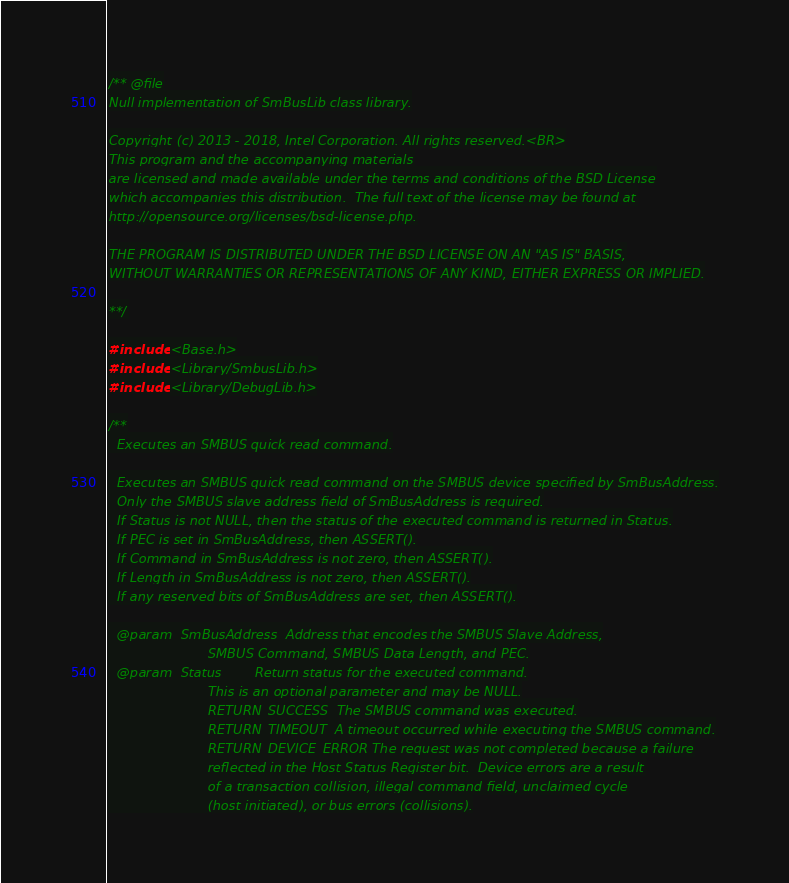<code> <loc_0><loc_0><loc_500><loc_500><_C_>/** @file
Null implementation of SmBusLib class library.

Copyright (c) 2013 - 2018, Intel Corporation. All rights reserved.<BR>
This program and the accompanying materials
are licensed and made available under the terms and conditions of the BSD License
which accompanies this distribution.  The full text of the license may be found at
http://opensource.org/licenses/bsd-license.php.

THE PROGRAM IS DISTRIBUTED UNDER THE BSD LICENSE ON AN "AS IS" BASIS,
WITHOUT WARRANTIES OR REPRESENTATIONS OF ANY KIND, EITHER EXPRESS OR IMPLIED.

**/

#include <Base.h>
#include <Library/SmbusLib.h>
#include <Library/DebugLib.h>

/**
  Executes an SMBUS quick read command.

  Executes an SMBUS quick read command on the SMBUS device specified by SmBusAddress.
  Only the SMBUS slave address field of SmBusAddress is required.
  If Status is not NULL, then the status of the executed command is returned in Status.
  If PEC is set in SmBusAddress, then ASSERT().
  If Command in SmBusAddress is not zero, then ASSERT().
  If Length in SmBusAddress is not zero, then ASSERT().
  If any reserved bits of SmBusAddress are set, then ASSERT().

  @param  SmBusAddress  Address that encodes the SMBUS Slave Address,
                        SMBUS Command, SMBUS Data Length, and PEC.
  @param  Status        Return status for the executed command.
                        This is an optional parameter and may be NULL.
                        RETURN_SUCCESS  The SMBUS command was executed.
                        RETURN_TIMEOUT  A timeout occurred while executing the SMBUS command.
                        RETURN_DEVICE_ERROR The request was not completed because a failure
                        reflected in the Host Status Register bit.  Device errors are a result
                        of a transaction collision, illegal command field, unclaimed cycle
                        (host initiated), or bus errors (collisions).</code> 